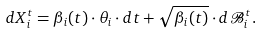<formula> <loc_0><loc_0><loc_500><loc_500>d X ^ { t } _ { i } = \beta _ { i } ( t ) \cdot \theta _ { i } \cdot d t + \sqrt { \beta _ { i } ( t ) } \cdot d \mathcal { B } ^ { t } _ { i } .</formula> 